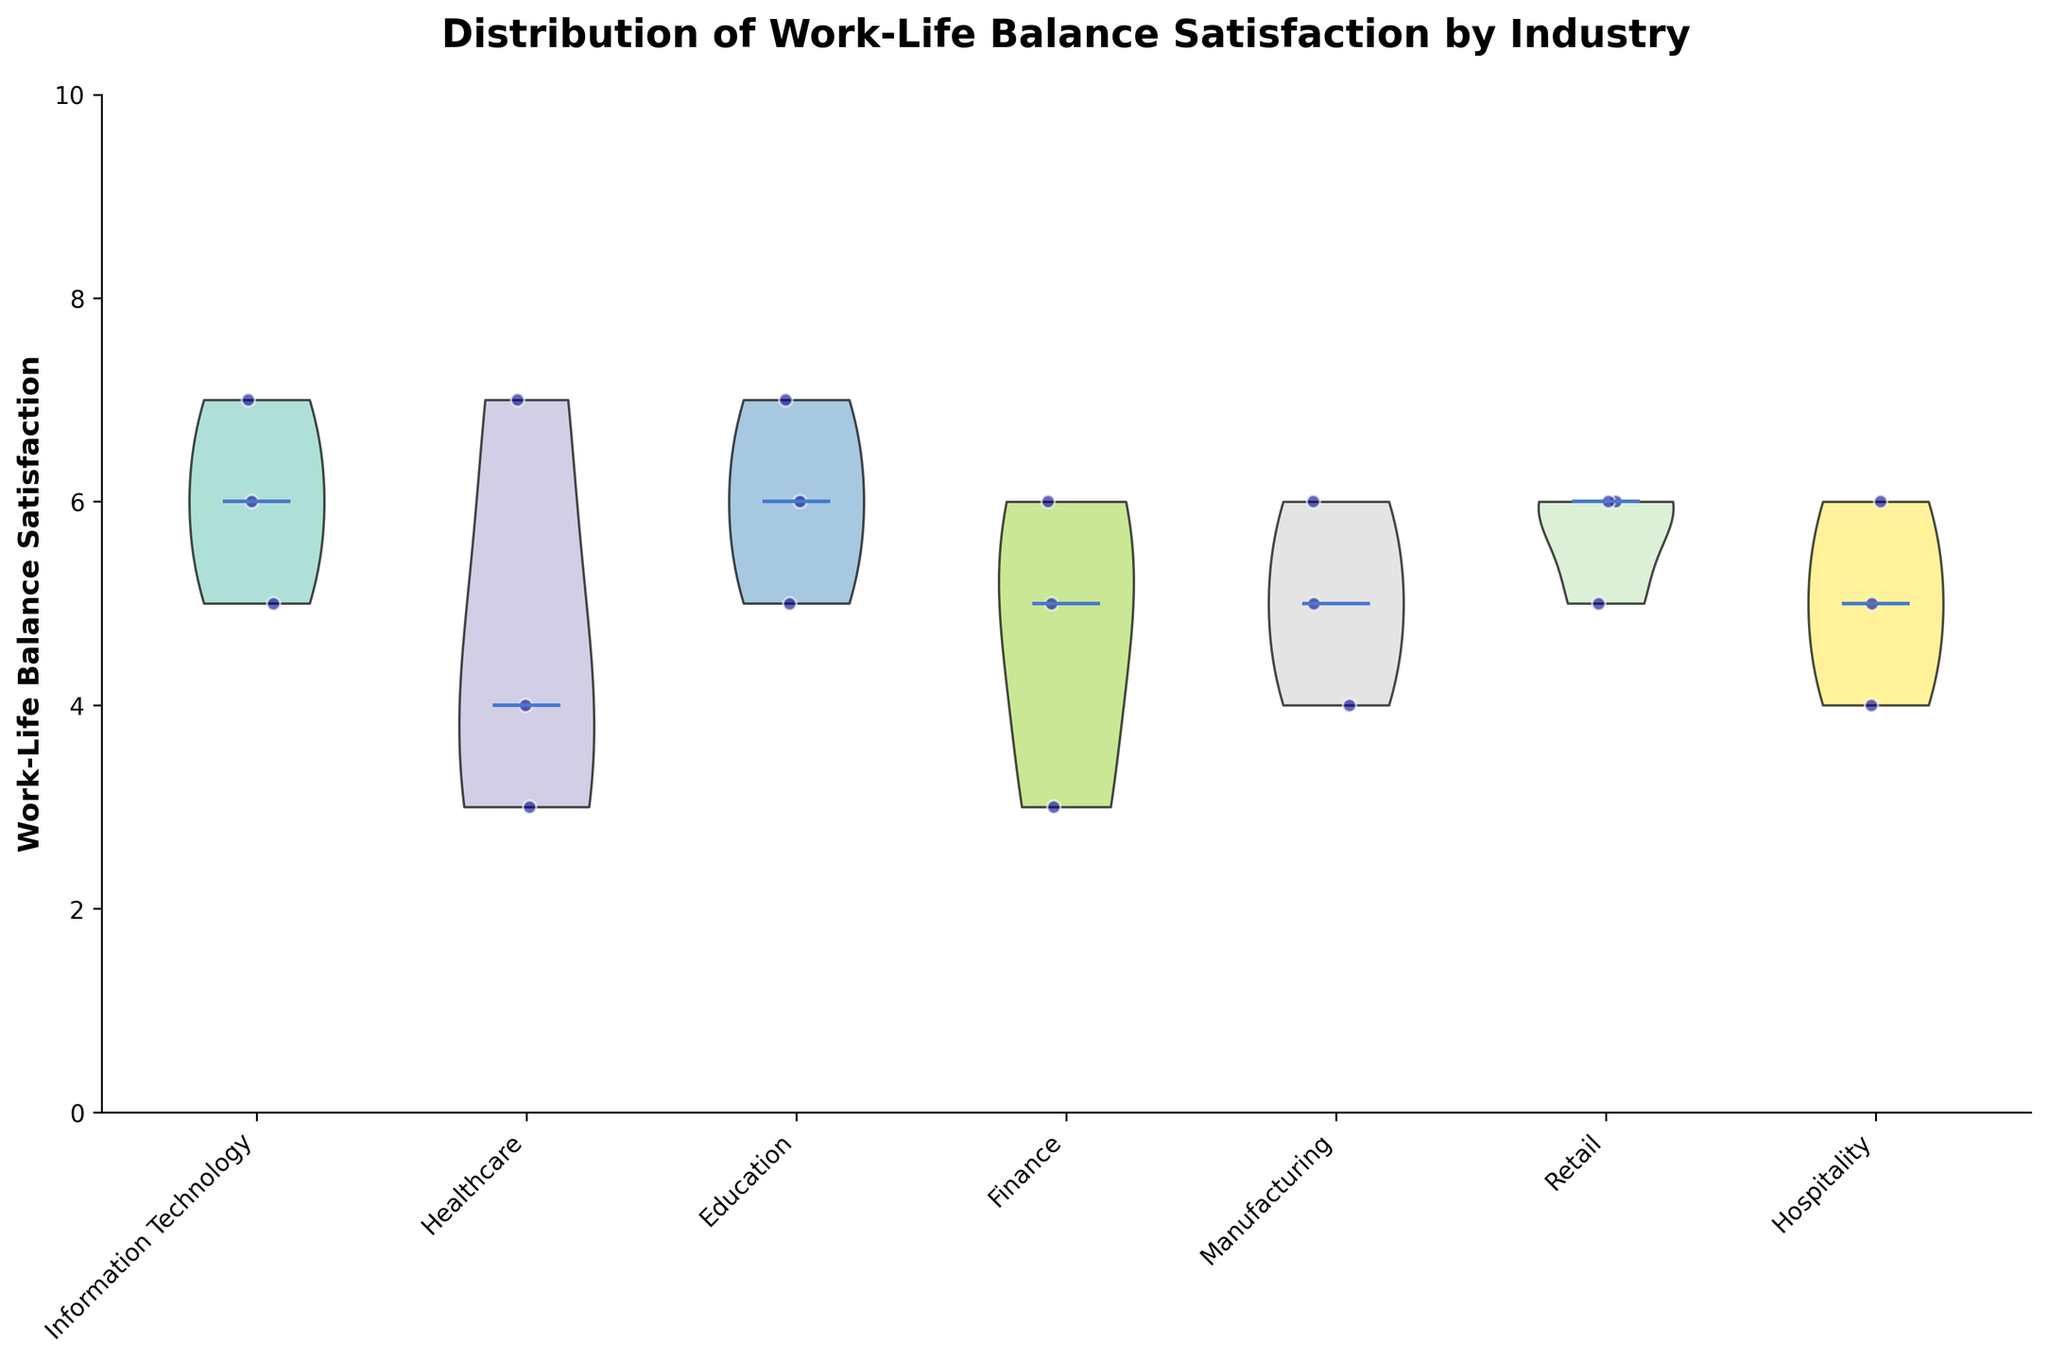What industries are compared in the figure? By looking at the x-axis labels, which represent different industries, we can see the industries being compared. The labels include Information Technology, Healthcare, Education, Finance, Manufacturing, Retail, and Hospitality.
Answer: Information Technology, Healthcare, Education, Finance, Manufacturing, Retail, Hospitality What is the title of the figure? The title is indicated at the top of the figure and provides a summary of what the chart represents. This helps in understanding the context of the data being presented.
Answer: Distribution of Work-Life Balance Satisfaction by Industry Which industry shows the highest median work-life balance satisfaction? To find this, we observe the central line within the violin plots of each industry. The line represents the median value. By comparing these lines across all the industries, we can determine the one with the highest median.
Answer: Retail Which industry has the most varied distribution of work-life balance satisfaction? A varied distribution is indicated by the width and spread of the violin plot. The wider and more spread out the plot, the more varied the distribution. Comparing these characteristics across all industries helps identify the one with the most variation.
Answer: Healthcare What is the work-life balance satisfaction range for jobs in Finance? The range is observed by looking at the extent of the violin plot's vertical span. For Finance, it spans from the lowest to the highest data points.
Answer: 3 to 6 Which job role in Healthcare has notably low work-life balance satisfaction? By observing the scatter points overlaying the violin plot in the Healthcare category and noting the job roles, we can identify the one with lower satisfaction values.
Answer: Surgeon How many job roles in Education have a work-life balance satisfaction of 6 or higher? By looking at the scatter points in the Education category and counting those with satisfaction values of 6 or higher.
Answer: 2 Is there a significant difference in work-life balance satisfaction between Information Technology and Hospitality? By comparing the shapes and medians of the violin plots for both industries, we can assess whether there is a marked difference in their distributions and central tendencies. Information Technology has higher median values and a more concentrated distribution.
Answer: Yes Which industry shows a clustering of satisfaction scores around 5? Clustering around a specific value is indicated by a concentration of scatter points around that value within the violin plot. Observing the distribution of scatter points helps identify the industry.
Answer: Manufacturing In which industry do we see more work-life balance satisfaction scores closer to 6? This can be identified by looking for violin plots where the density of points or the body of the Violin plot is more pronounced around the satisfaction score of 6.
Answer: Retail 